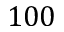Convert formula to latex. <formula><loc_0><loc_0><loc_500><loc_500>1 0 0</formula> 